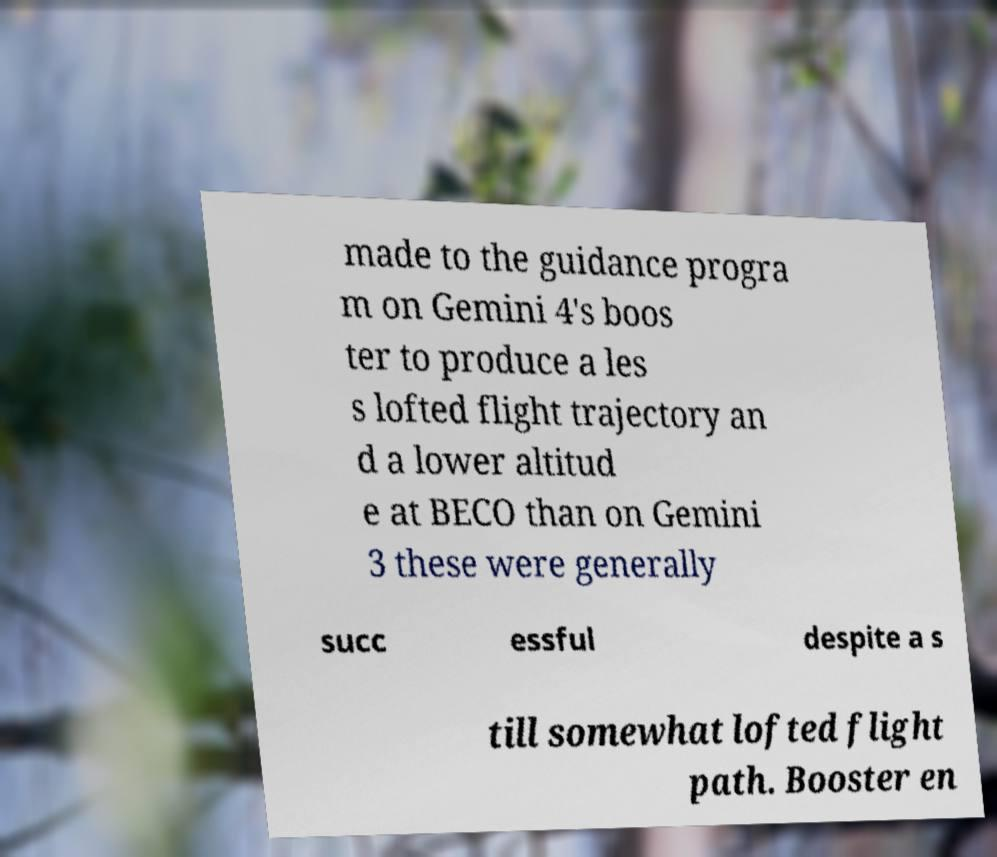Can you accurately transcribe the text from the provided image for me? made to the guidance progra m on Gemini 4's boos ter to produce a les s lofted flight trajectory an d a lower altitud e at BECO than on Gemini 3 these were generally succ essful despite a s till somewhat lofted flight path. Booster en 